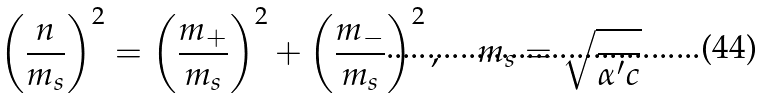<formula> <loc_0><loc_0><loc_500><loc_500>\left ( \frac { n } { m _ { s } } \right ) ^ { 2 } = \left ( \frac { m _ { + } } { m _ { s } } \right ) ^ { 2 } + \left ( \frac { m _ { - } } { m _ { s } } \right ) ^ { 2 } , \quad m _ { s } = \sqrt { \frac { } { \alpha ^ { \prime } c } }</formula> 